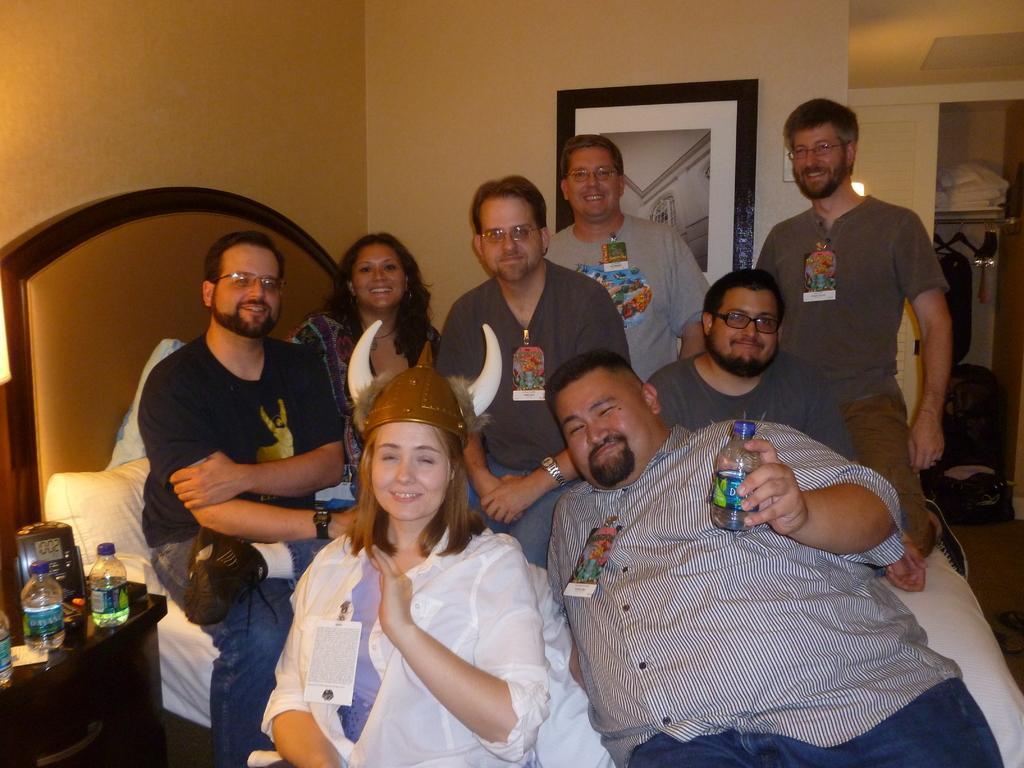In one or two sentences, can you explain what this image depicts? In this picture we can see a group of people smoking, bed, pillows, bottles, frame on the wall and in the background we can see clothes. 